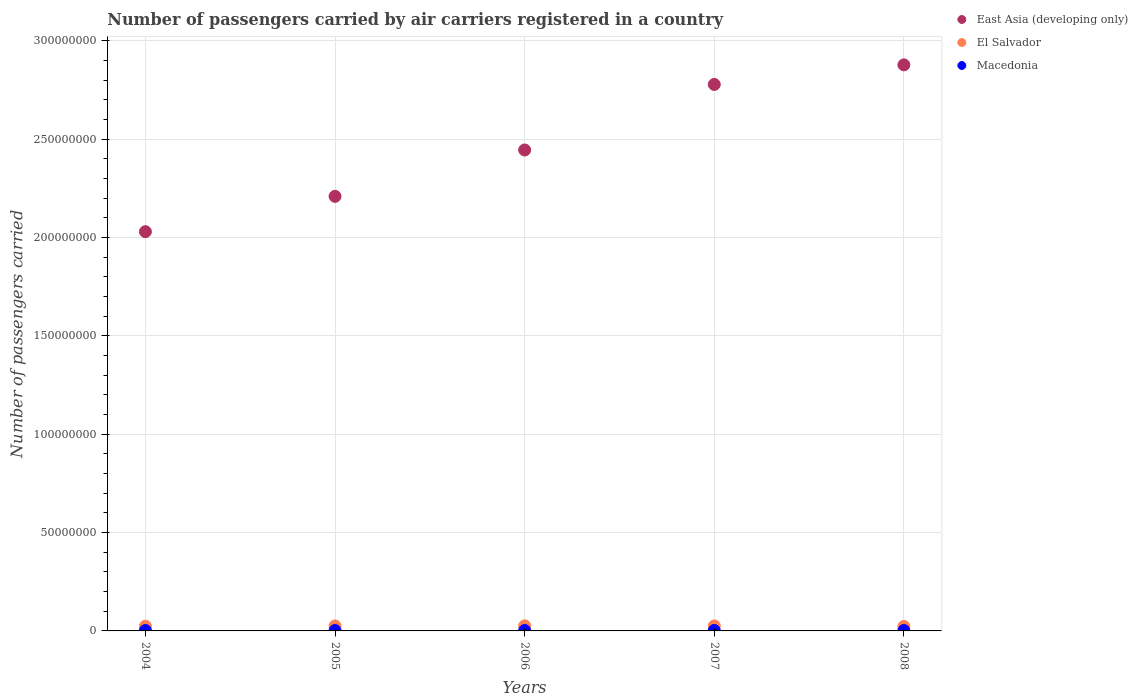How many different coloured dotlines are there?
Offer a terse response. 3. What is the number of passengers carried by air carriers in East Asia (developing only) in 2007?
Provide a short and direct response. 2.78e+08. Across all years, what is the maximum number of passengers carried by air carriers in East Asia (developing only)?
Keep it short and to the point. 2.88e+08. Across all years, what is the minimum number of passengers carried by air carriers in Macedonia?
Offer a very short reply. 1.92e+05. In which year was the number of passengers carried by air carriers in El Salvador maximum?
Your answer should be compact. 2006. What is the total number of passengers carried by air carriers in East Asia (developing only) in the graph?
Your answer should be compact. 1.23e+09. What is the difference between the number of passengers carried by air carriers in Macedonia in 2004 and that in 2007?
Provide a succinct answer. -2.35e+04. What is the difference between the number of passengers carried by air carriers in East Asia (developing only) in 2006 and the number of passengers carried by air carriers in Macedonia in 2007?
Make the answer very short. 2.44e+08. What is the average number of passengers carried by air carriers in Macedonia per year?
Your answer should be very brief. 2.09e+05. In the year 2007, what is the difference between the number of passengers carried by air carriers in East Asia (developing only) and number of passengers carried by air carriers in Macedonia?
Ensure brevity in your answer.  2.78e+08. What is the ratio of the number of passengers carried by air carriers in East Asia (developing only) in 2005 to that in 2008?
Keep it short and to the point. 0.77. What is the difference between the highest and the second highest number of passengers carried by air carriers in Macedonia?
Your response must be concise. 2.35e+04. What is the difference between the highest and the lowest number of passengers carried by air carriers in Macedonia?
Your answer should be compact. 4.24e+04. In how many years, is the number of passengers carried by air carriers in East Asia (developing only) greater than the average number of passengers carried by air carriers in East Asia (developing only) taken over all years?
Offer a very short reply. 2. Is the sum of the number of passengers carried by air carriers in Macedonia in 2004 and 2007 greater than the maximum number of passengers carried by air carriers in East Asia (developing only) across all years?
Your answer should be very brief. No. Is it the case that in every year, the sum of the number of passengers carried by air carriers in Macedonia and number of passengers carried by air carriers in East Asia (developing only)  is greater than the number of passengers carried by air carriers in El Salvador?
Offer a terse response. Yes. Is the number of passengers carried by air carriers in El Salvador strictly greater than the number of passengers carried by air carriers in Macedonia over the years?
Offer a terse response. Yes. How many dotlines are there?
Ensure brevity in your answer.  3. How many years are there in the graph?
Your response must be concise. 5. Where does the legend appear in the graph?
Offer a terse response. Top right. How many legend labels are there?
Ensure brevity in your answer.  3. How are the legend labels stacked?
Make the answer very short. Vertical. What is the title of the graph?
Provide a short and direct response. Number of passengers carried by air carriers registered in a country. Does "Iceland" appear as one of the legend labels in the graph?
Provide a short and direct response. No. What is the label or title of the Y-axis?
Offer a very short reply. Number of passengers carried. What is the Number of passengers carried in East Asia (developing only) in 2004?
Give a very brief answer. 2.03e+08. What is the Number of passengers carried of El Salvador in 2004?
Provide a succinct answer. 2.39e+06. What is the Number of passengers carried in Macedonia in 2004?
Ensure brevity in your answer.  2.11e+05. What is the Number of passengers carried of East Asia (developing only) in 2005?
Provide a succinct answer. 2.21e+08. What is the Number of passengers carried in El Salvador in 2005?
Provide a succinct answer. 2.54e+06. What is the Number of passengers carried of Macedonia in 2005?
Provide a short and direct response. 1.92e+05. What is the Number of passengers carried of East Asia (developing only) in 2006?
Ensure brevity in your answer.  2.44e+08. What is the Number of passengers carried in El Salvador in 2006?
Ensure brevity in your answer.  2.58e+06. What is the Number of passengers carried in Macedonia in 2006?
Make the answer very short. 2.09e+05. What is the Number of passengers carried of East Asia (developing only) in 2007?
Ensure brevity in your answer.  2.78e+08. What is the Number of passengers carried in El Salvador in 2007?
Provide a succinct answer. 2.54e+06. What is the Number of passengers carried of Macedonia in 2007?
Ensure brevity in your answer.  2.34e+05. What is the Number of passengers carried of East Asia (developing only) in 2008?
Keep it short and to the point. 2.88e+08. What is the Number of passengers carried of El Salvador in 2008?
Provide a short and direct response. 2.28e+06. What is the Number of passengers carried of Macedonia in 2008?
Offer a very short reply. 1.96e+05. Across all years, what is the maximum Number of passengers carried of East Asia (developing only)?
Keep it short and to the point. 2.88e+08. Across all years, what is the maximum Number of passengers carried of El Salvador?
Your response must be concise. 2.58e+06. Across all years, what is the maximum Number of passengers carried of Macedonia?
Keep it short and to the point. 2.34e+05. Across all years, what is the minimum Number of passengers carried in East Asia (developing only)?
Give a very brief answer. 2.03e+08. Across all years, what is the minimum Number of passengers carried in El Salvador?
Your answer should be compact. 2.28e+06. Across all years, what is the minimum Number of passengers carried in Macedonia?
Your answer should be very brief. 1.92e+05. What is the total Number of passengers carried of East Asia (developing only) in the graph?
Ensure brevity in your answer.  1.23e+09. What is the total Number of passengers carried of El Salvador in the graph?
Offer a very short reply. 1.23e+07. What is the total Number of passengers carried in Macedonia in the graph?
Provide a succinct answer. 1.04e+06. What is the difference between the Number of passengers carried in East Asia (developing only) in 2004 and that in 2005?
Offer a terse response. -1.79e+07. What is the difference between the Number of passengers carried of El Salvador in 2004 and that in 2005?
Keep it short and to the point. -1.49e+05. What is the difference between the Number of passengers carried of Macedonia in 2004 and that in 2005?
Your response must be concise. 1.89e+04. What is the difference between the Number of passengers carried in East Asia (developing only) in 2004 and that in 2006?
Your response must be concise. -4.15e+07. What is the difference between the Number of passengers carried in El Salvador in 2004 and that in 2006?
Offer a terse response. -1.88e+05. What is the difference between the Number of passengers carried in Macedonia in 2004 and that in 2006?
Your answer should be very brief. 1620. What is the difference between the Number of passengers carried of East Asia (developing only) in 2004 and that in 2007?
Give a very brief answer. -7.48e+07. What is the difference between the Number of passengers carried of El Salvador in 2004 and that in 2007?
Your response must be concise. -1.46e+05. What is the difference between the Number of passengers carried in Macedonia in 2004 and that in 2007?
Provide a short and direct response. -2.35e+04. What is the difference between the Number of passengers carried of East Asia (developing only) in 2004 and that in 2008?
Give a very brief answer. -8.48e+07. What is the difference between the Number of passengers carried of El Salvador in 2004 and that in 2008?
Offer a terse response. 1.11e+05. What is the difference between the Number of passengers carried of Macedonia in 2004 and that in 2008?
Your answer should be compact. 1.45e+04. What is the difference between the Number of passengers carried of East Asia (developing only) in 2005 and that in 2006?
Give a very brief answer. -2.36e+07. What is the difference between the Number of passengers carried in El Salvador in 2005 and that in 2006?
Provide a succinct answer. -3.86e+04. What is the difference between the Number of passengers carried in Macedonia in 2005 and that in 2006?
Make the answer very short. -1.73e+04. What is the difference between the Number of passengers carried of East Asia (developing only) in 2005 and that in 2007?
Your answer should be compact. -5.69e+07. What is the difference between the Number of passengers carried in El Salvador in 2005 and that in 2007?
Ensure brevity in your answer.  3744. What is the difference between the Number of passengers carried in Macedonia in 2005 and that in 2007?
Ensure brevity in your answer.  -4.24e+04. What is the difference between the Number of passengers carried in East Asia (developing only) in 2005 and that in 2008?
Give a very brief answer. -6.68e+07. What is the difference between the Number of passengers carried of El Salvador in 2005 and that in 2008?
Keep it short and to the point. 2.61e+05. What is the difference between the Number of passengers carried in Macedonia in 2005 and that in 2008?
Make the answer very short. -4443. What is the difference between the Number of passengers carried of East Asia (developing only) in 2006 and that in 2007?
Make the answer very short. -3.33e+07. What is the difference between the Number of passengers carried of El Salvador in 2006 and that in 2007?
Offer a very short reply. 4.23e+04. What is the difference between the Number of passengers carried of Macedonia in 2006 and that in 2007?
Ensure brevity in your answer.  -2.51e+04. What is the difference between the Number of passengers carried of East Asia (developing only) in 2006 and that in 2008?
Make the answer very short. -4.33e+07. What is the difference between the Number of passengers carried in El Salvador in 2006 and that in 2008?
Offer a terse response. 2.99e+05. What is the difference between the Number of passengers carried in Macedonia in 2006 and that in 2008?
Your answer should be compact. 1.28e+04. What is the difference between the Number of passengers carried in East Asia (developing only) in 2007 and that in 2008?
Provide a short and direct response. -9.95e+06. What is the difference between the Number of passengers carried in El Salvador in 2007 and that in 2008?
Your response must be concise. 2.57e+05. What is the difference between the Number of passengers carried in Macedonia in 2007 and that in 2008?
Offer a terse response. 3.79e+04. What is the difference between the Number of passengers carried in East Asia (developing only) in 2004 and the Number of passengers carried in El Salvador in 2005?
Give a very brief answer. 2.00e+08. What is the difference between the Number of passengers carried in East Asia (developing only) in 2004 and the Number of passengers carried in Macedonia in 2005?
Your answer should be compact. 2.03e+08. What is the difference between the Number of passengers carried in El Salvador in 2004 and the Number of passengers carried in Macedonia in 2005?
Offer a terse response. 2.20e+06. What is the difference between the Number of passengers carried of East Asia (developing only) in 2004 and the Number of passengers carried of El Salvador in 2006?
Your answer should be very brief. 2.00e+08. What is the difference between the Number of passengers carried in East Asia (developing only) in 2004 and the Number of passengers carried in Macedonia in 2006?
Keep it short and to the point. 2.03e+08. What is the difference between the Number of passengers carried in El Salvador in 2004 and the Number of passengers carried in Macedonia in 2006?
Make the answer very short. 2.18e+06. What is the difference between the Number of passengers carried of East Asia (developing only) in 2004 and the Number of passengers carried of El Salvador in 2007?
Keep it short and to the point. 2.00e+08. What is the difference between the Number of passengers carried of East Asia (developing only) in 2004 and the Number of passengers carried of Macedonia in 2007?
Offer a very short reply. 2.03e+08. What is the difference between the Number of passengers carried in El Salvador in 2004 and the Number of passengers carried in Macedonia in 2007?
Provide a succinct answer. 2.16e+06. What is the difference between the Number of passengers carried of East Asia (developing only) in 2004 and the Number of passengers carried of El Salvador in 2008?
Offer a very short reply. 2.01e+08. What is the difference between the Number of passengers carried of East Asia (developing only) in 2004 and the Number of passengers carried of Macedonia in 2008?
Keep it short and to the point. 2.03e+08. What is the difference between the Number of passengers carried of El Salvador in 2004 and the Number of passengers carried of Macedonia in 2008?
Offer a terse response. 2.19e+06. What is the difference between the Number of passengers carried of East Asia (developing only) in 2005 and the Number of passengers carried of El Salvador in 2006?
Give a very brief answer. 2.18e+08. What is the difference between the Number of passengers carried in East Asia (developing only) in 2005 and the Number of passengers carried in Macedonia in 2006?
Your answer should be very brief. 2.21e+08. What is the difference between the Number of passengers carried in El Salvador in 2005 and the Number of passengers carried in Macedonia in 2006?
Make the answer very short. 2.33e+06. What is the difference between the Number of passengers carried in East Asia (developing only) in 2005 and the Number of passengers carried in El Salvador in 2007?
Your answer should be very brief. 2.18e+08. What is the difference between the Number of passengers carried of East Asia (developing only) in 2005 and the Number of passengers carried of Macedonia in 2007?
Provide a short and direct response. 2.21e+08. What is the difference between the Number of passengers carried in El Salvador in 2005 and the Number of passengers carried in Macedonia in 2007?
Ensure brevity in your answer.  2.31e+06. What is the difference between the Number of passengers carried in East Asia (developing only) in 2005 and the Number of passengers carried in El Salvador in 2008?
Make the answer very short. 2.19e+08. What is the difference between the Number of passengers carried in East Asia (developing only) in 2005 and the Number of passengers carried in Macedonia in 2008?
Your answer should be very brief. 2.21e+08. What is the difference between the Number of passengers carried in El Salvador in 2005 and the Number of passengers carried in Macedonia in 2008?
Give a very brief answer. 2.34e+06. What is the difference between the Number of passengers carried in East Asia (developing only) in 2006 and the Number of passengers carried in El Salvador in 2007?
Offer a very short reply. 2.42e+08. What is the difference between the Number of passengers carried in East Asia (developing only) in 2006 and the Number of passengers carried in Macedonia in 2007?
Make the answer very short. 2.44e+08. What is the difference between the Number of passengers carried of El Salvador in 2006 and the Number of passengers carried of Macedonia in 2007?
Your answer should be very brief. 2.34e+06. What is the difference between the Number of passengers carried of East Asia (developing only) in 2006 and the Number of passengers carried of El Salvador in 2008?
Your response must be concise. 2.42e+08. What is the difference between the Number of passengers carried of East Asia (developing only) in 2006 and the Number of passengers carried of Macedonia in 2008?
Your answer should be compact. 2.44e+08. What is the difference between the Number of passengers carried in El Salvador in 2006 and the Number of passengers carried in Macedonia in 2008?
Your answer should be compact. 2.38e+06. What is the difference between the Number of passengers carried of East Asia (developing only) in 2007 and the Number of passengers carried of El Salvador in 2008?
Offer a terse response. 2.75e+08. What is the difference between the Number of passengers carried in East Asia (developing only) in 2007 and the Number of passengers carried in Macedonia in 2008?
Provide a short and direct response. 2.78e+08. What is the difference between the Number of passengers carried in El Salvador in 2007 and the Number of passengers carried in Macedonia in 2008?
Offer a very short reply. 2.34e+06. What is the average Number of passengers carried in East Asia (developing only) per year?
Offer a terse response. 2.47e+08. What is the average Number of passengers carried in El Salvador per year?
Your answer should be very brief. 2.47e+06. What is the average Number of passengers carried in Macedonia per year?
Provide a succinct answer. 2.09e+05. In the year 2004, what is the difference between the Number of passengers carried of East Asia (developing only) and Number of passengers carried of El Salvador?
Your response must be concise. 2.01e+08. In the year 2004, what is the difference between the Number of passengers carried in East Asia (developing only) and Number of passengers carried in Macedonia?
Your response must be concise. 2.03e+08. In the year 2004, what is the difference between the Number of passengers carried in El Salvador and Number of passengers carried in Macedonia?
Ensure brevity in your answer.  2.18e+06. In the year 2005, what is the difference between the Number of passengers carried in East Asia (developing only) and Number of passengers carried in El Salvador?
Your answer should be compact. 2.18e+08. In the year 2005, what is the difference between the Number of passengers carried in East Asia (developing only) and Number of passengers carried in Macedonia?
Ensure brevity in your answer.  2.21e+08. In the year 2005, what is the difference between the Number of passengers carried of El Salvador and Number of passengers carried of Macedonia?
Make the answer very short. 2.35e+06. In the year 2006, what is the difference between the Number of passengers carried of East Asia (developing only) and Number of passengers carried of El Salvador?
Provide a succinct answer. 2.42e+08. In the year 2006, what is the difference between the Number of passengers carried in East Asia (developing only) and Number of passengers carried in Macedonia?
Provide a succinct answer. 2.44e+08. In the year 2006, what is the difference between the Number of passengers carried of El Salvador and Number of passengers carried of Macedonia?
Make the answer very short. 2.37e+06. In the year 2007, what is the difference between the Number of passengers carried in East Asia (developing only) and Number of passengers carried in El Salvador?
Give a very brief answer. 2.75e+08. In the year 2007, what is the difference between the Number of passengers carried in East Asia (developing only) and Number of passengers carried in Macedonia?
Keep it short and to the point. 2.78e+08. In the year 2007, what is the difference between the Number of passengers carried of El Salvador and Number of passengers carried of Macedonia?
Give a very brief answer. 2.30e+06. In the year 2008, what is the difference between the Number of passengers carried of East Asia (developing only) and Number of passengers carried of El Salvador?
Provide a succinct answer. 2.85e+08. In the year 2008, what is the difference between the Number of passengers carried in East Asia (developing only) and Number of passengers carried in Macedonia?
Your answer should be very brief. 2.88e+08. In the year 2008, what is the difference between the Number of passengers carried in El Salvador and Number of passengers carried in Macedonia?
Your answer should be very brief. 2.08e+06. What is the ratio of the Number of passengers carried in East Asia (developing only) in 2004 to that in 2005?
Ensure brevity in your answer.  0.92. What is the ratio of the Number of passengers carried of Macedonia in 2004 to that in 2005?
Give a very brief answer. 1.1. What is the ratio of the Number of passengers carried of East Asia (developing only) in 2004 to that in 2006?
Offer a very short reply. 0.83. What is the ratio of the Number of passengers carried in El Salvador in 2004 to that in 2006?
Keep it short and to the point. 0.93. What is the ratio of the Number of passengers carried of Macedonia in 2004 to that in 2006?
Make the answer very short. 1.01. What is the ratio of the Number of passengers carried of East Asia (developing only) in 2004 to that in 2007?
Your answer should be very brief. 0.73. What is the ratio of the Number of passengers carried of El Salvador in 2004 to that in 2007?
Your response must be concise. 0.94. What is the ratio of the Number of passengers carried in Macedonia in 2004 to that in 2007?
Ensure brevity in your answer.  0.9. What is the ratio of the Number of passengers carried of East Asia (developing only) in 2004 to that in 2008?
Your answer should be very brief. 0.71. What is the ratio of the Number of passengers carried of El Salvador in 2004 to that in 2008?
Your response must be concise. 1.05. What is the ratio of the Number of passengers carried of Macedonia in 2004 to that in 2008?
Your answer should be very brief. 1.07. What is the ratio of the Number of passengers carried of East Asia (developing only) in 2005 to that in 2006?
Your answer should be very brief. 0.9. What is the ratio of the Number of passengers carried in El Salvador in 2005 to that in 2006?
Your answer should be very brief. 0.98. What is the ratio of the Number of passengers carried in Macedonia in 2005 to that in 2006?
Give a very brief answer. 0.92. What is the ratio of the Number of passengers carried of East Asia (developing only) in 2005 to that in 2007?
Make the answer very short. 0.8. What is the ratio of the Number of passengers carried of El Salvador in 2005 to that in 2007?
Your response must be concise. 1. What is the ratio of the Number of passengers carried in Macedonia in 2005 to that in 2007?
Keep it short and to the point. 0.82. What is the ratio of the Number of passengers carried in East Asia (developing only) in 2005 to that in 2008?
Provide a succinct answer. 0.77. What is the ratio of the Number of passengers carried in El Salvador in 2005 to that in 2008?
Provide a succinct answer. 1.11. What is the ratio of the Number of passengers carried of Macedonia in 2005 to that in 2008?
Make the answer very short. 0.98. What is the ratio of the Number of passengers carried of El Salvador in 2006 to that in 2007?
Give a very brief answer. 1.02. What is the ratio of the Number of passengers carried in Macedonia in 2006 to that in 2007?
Keep it short and to the point. 0.89. What is the ratio of the Number of passengers carried of East Asia (developing only) in 2006 to that in 2008?
Your response must be concise. 0.85. What is the ratio of the Number of passengers carried in El Salvador in 2006 to that in 2008?
Ensure brevity in your answer.  1.13. What is the ratio of the Number of passengers carried of Macedonia in 2006 to that in 2008?
Offer a very short reply. 1.07. What is the ratio of the Number of passengers carried of East Asia (developing only) in 2007 to that in 2008?
Provide a succinct answer. 0.97. What is the ratio of the Number of passengers carried of El Salvador in 2007 to that in 2008?
Offer a terse response. 1.11. What is the ratio of the Number of passengers carried of Macedonia in 2007 to that in 2008?
Your answer should be compact. 1.19. What is the difference between the highest and the second highest Number of passengers carried of East Asia (developing only)?
Provide a succinct answer. 9.95e+06. What is the difference between the highest and the second highest Number of passengers carried of El Salvador?
Provide a succinct answer. 3.86e+04. What is the difference between the highest and the second highest Number of passengers carried of Macedonia?
Make the answer very short. 2.35e+04. What is the difference between the highest and the lowest Number of passengers carried in East Asia (developing only)?
Provide a succinct answer. 8.48e+07. What is the difference between the highest and the lowest Number of passengers carried of El Salvador?
Offer a very short reply. 2.99e+05. What is the difference between the highest and the lowest Number of passengers carried in Macedonia?
Offer a terse response. 4.24e+04. 